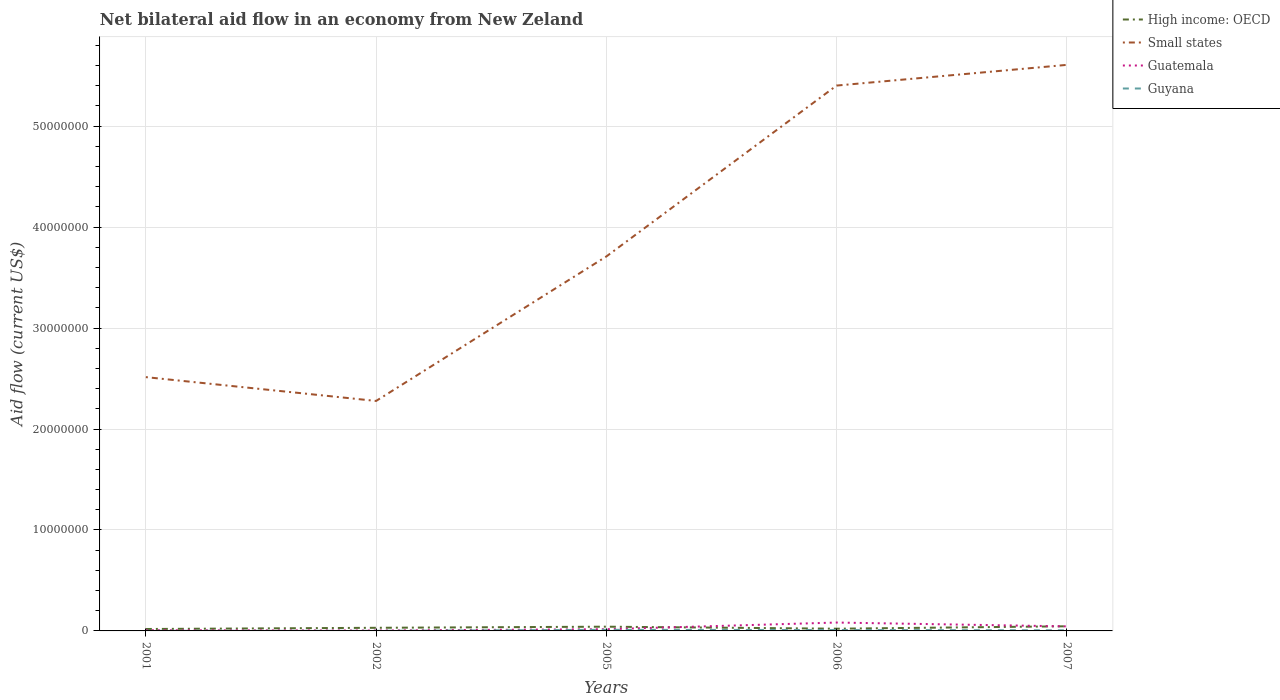How many different coloured lines are there?
Keep it short and to the point. 4. Does the line corresponding to Guyana intersect with the line corresponding to Small states?
Make the answer very short. No. Across all years, what is the maximum net bilateral aid flow in Guyana?
Offer a very short reply. 10000. In which year was the net bilateral aid flow in Small states maximum?
Keep it short and to the point. 2002. What is the total net bilateral aid flow in Small states in the graph?
Ensure brevity in your answer.  -2.05e+06. What is the difference between the highest and the second highest net bilateral aid flow in Guyana?
Keep it short and to the point. 1.00e+05. How many lines are there?
Your answer should be compact. 4. How many years are there in the graph?
Keep it short and to the point. 5. What is the difference between two consecutive major ticks on the Y-axis?
Your answer should be compact. 1.00e+07. Where does the legend appear in the graph?
Your answer should be very brief. Top right. How many legend labels are there?
Offer a very short reply. 4. How are the legend labels stacked?
Ensure brevity in your answer.  Vertical. What is the title of the graph?
Offer a terse response. Net bilateral aid flow in an economy from New Zeland. What is the label or title of the Y-axis?
Your answer should be very brief. Aid flow (current US$). What is the Aid flow (current US$) in Small states in 2001?
Provide a short and direct response. 2.51e+07. What is the Aid flow (current US$) of Guatemala in 2001?
Offer a very short reply. 7.00e+04. What is the Aid flow (current US$) of High income: OECD in 2002?
Provide a succinct answer. 3.10e+05. What is the Aid flow (current US$) of Small states in 2002?
Ensure brevity in your answer.  2.28e+07. What is the Aid flow (current US$) in Guatemala in 2002?
Provide a short and direct response. 4.00e+04. What is the Aid flow (current US$) in Small states in 2005?
Offer a very short reply. 3.71e+07. What is the Aid flow (current US$) in Guatemala in 2005?
Keep it short and to the point. 1.70e+05. What is the Aid flow (current US$) of High income: OECD in 2006?
Offer a terse response. 2.20e+05. What is the Aid flow (current US$) in Small states in 2006?
Offer a very short reply. 5.40e+07. What is the Aid flow (current US$) of Guatemala in 2006?
Keep it short and to the point. 8.30e+05. What is the Aid flow (current US$) of Small states in 2007?
Your response must be concise. 5.61e+07. What is the Aid flow (current US$) of Guatemala in 2007?
Ensure brevity in your answer.  4.50e+05. Across all years, what is the maximum Aid flow (current US$) in Small states?
Offer a very short reply. 5.61e+07. Across all years, what is the maximum Aid flow (current US$) in Guatemala?
Provide a succinct answer. 8.30e+05. Across all years, what is the minimum Aid flow (current US$) of High income: OECD?
Your answer should be compact. 1.90e+05. Across all years, what is the minimum Aid flow (current US$) of Small states?
Make the answer very short. 2.28e+07. Across all years, what is the minimum Aid flow (current US$) in Guatemala?
Your answer should be compact. 4.00e+04. Across all years, what is the minimum Aid flow (current US$) of Guyana?
Offer a very short reply. 10000. What is the total Aid flow (current US$) in High income: OECD in the graph?
Give a very brief answer. 1.60e+06. What is the total Aid flow (current US$) in Small states in the graph?
Your response must be concise. 1.95e+08. What is the total Aid flow (current US$) in Guatemala in the graph?
Your answer should be very brief. 1.56e+06. What is the total Aid flow (current US$) of Guyana in the graph?
Offer a very short reply. 2.80e+05. What is the difference between the Aid flow (current US$) of Small states in 2001 and that in 2002?
Provide a short and direct response. 2.36e+06. What is the difference between the Aid flow (current US$) in Guatemala in 2001 and that in 2002?
Your answer should be very brief. 3.00e+04. What is the difference between the Aid flow (current US$) in High income: OECD in 2001 and that in 2005?
Your response must be concise. -2.30e+05. What is the difference between the Aid flow (current US$) of Small states in 2001 and that in 2005?
Make the answer very short. -1.20e+07. What is the difference between the Aid flow (current US$) in Small states in 2001 and that in 2006?
Keep it short and to the point. -2.89e+07. What is the difference between the Aid flow (current US$) in Guatemala in 2001 and that in 2006?
Keep it short and to the point. -7.60e+05. What is the difference between the Aid flow (current US$) of Guyana in 2001 and that in 2006?
Ensure brevity in your answer.  -8.00e+04. What is the difference between the Aid flow (current US$) in Small states in 2001 and that in 2007?
Ensure brevity in your answer.  -3.09e+07. What is the difference between the Aid flow (current US$) in Guatemala in 2001 and that in 2007?
Your answer should be compact. -3.80e+05. What is the difference between the Aid flow (current US$) in High income: OECD in 2002 and that in 2005?
Your answer should be compact. -1.10e+05. What is the difference between the Aid flow (current US$) of Small states in 2002 and that in 2005?
Your answer should be very brief. -1.43e+07. What is the difference between the Aid flow (current US$) of Guyana in 2002 and that in 2005?
Make the answer very short. -1.00e+05. What is the difference between the Aid flow (current US$) in High income: OECD in 2002 and that in 2006?
Keep it short and to the point. 9.00e+04. What is the difference between the Aid flow (current US$) in Small states in 2002 and that in 2006?
Provide a succinct answer. -3.12e+07. What is the difference between the Aid flow (current US$) of Guatemala in 2002 and that in 2006?
Your answer should be very brief. -7.90e+05. What is the difference between the Aid flow (current US$) in Guyana in 2002 and that in 2006?
Keep it short and to the point. -8.00e+04. What is the difference between the Aid flow (current US$) of Small states in 2002 and that in 2007?
Make the answer very short. -3.33e+07. What is the difference between the Aid flow (current US$) of Guatemala in 2002 and that in 2007?
Provide a succinct answer. -4.10e+05. What is the difference between the Aid flow (current US$) in High income: OECD in 2005 and that in 2006?
Offer a very short reply. 2.00e+05. What is the difference between the Aid flow (current US$) of Small states in 2005 and that in 2006?
Give a very brief answer. -1.69e+07. What is the difference between the Aid flow (current US$) of Guatemala in 2005 and that in 2006?
Give a very brief answer. -6.60e+05. What is the difference between the Aid flow (current US$) in Small states in 2005 and that in 2007?
Provide a succinct answer. -1.90e+07. What is the difference between the Aid flow (current US$) in Guatemala in 2005 and that in 2007?
Offer a very short reply. -2.80e+05. What is the difference between the Aid flow (current US$) in Guyana in 2005 and that in 2007?
Your response must be concise. 5.00e+04. What is the difference between the Aid flow (current US$) of High income: OECD in 2006 and that in 2007?
Your response must be concise. -2.40e+05. What is the difference between the Aid flow (current US$) in Small states in 2006 and that in 2007?
Offer a terse response. -2.05e+06. What is the difference between the Aid flow (current US$) in Guatemala in 2006 and that in 2007?
Offer a very short reply. 3.80e+05. What is the difference between the Aid flow (current US$) in High income: OECD in 2001 and the Aid flow (current US$) in Small states in 2002?
Ensure brevity in your answer.  -2.26e+07. What is the difference between the Aid flow (current US$) of High income: OECD in 2001 and the Aid flow (current US$) of Guyana in 2002?
Give a very brief answer. 1.80e+05. What is the difference between the Aid flow (current US$) in Small states in 2001 and the Aid flow (current US$) in Guatemala in 2002?
Make the answer very short. 2.51e+07. What is the difference between the Aid flow (current US$) of Small states in 2001 and the Aid flow (current US$) of Guyana in 2002?
Provide a succinct answer. 2.51e+07. What is the difference between the Aid flow (current US$) in High income: OECD in 2001 and the Aid flow (current US$) in Small states in 2005?
Your response must be concise. -3.69e+07. What is the difference between the Aid flow (current US$) of Small states in 2001 and the Aid flow (current US$) of Guatemala in 2005?
Provide a short and direct response. 2.50e+07. What is the difference between the Aid flow (current US$) in Small states in 2001 and the Aid flow (current US$) in Guyana in 2005?
Give a very brief answer. 2.50e+07. What is the difference between the Aid flow (current US$) in High income: OECD in 2001 and the Aid flow (current US$) in Small states in 2006?
Your answer should be compact. -5.38e+07. What is the difference between the Aid flow (current US$) in High income: OECD in 2001 and the Aid flow (current US$) in Guatemala in 2006?
Ensure brevity in your answer.  -6.40e+05. What is the difference between the Aid flow (current US$) of Small states in 2001 and the Aid flow (current US$) of Guatemala in 2006?
Provide a succinct answer. 2.43e+07. What is the difference between the Aid flow (current US$) in Small states in 2001 and the Aid flow (current US$) in Guyana in 2006?
Your answer should be compact. 2.50e+07. What is the difference between the Aid flow (current US$) of Guatemala in 2001 and the Aid flow (current US$) of Guyana in 2006?
Offer a terse response. -2.00e+04. What is the difference between the Aid flow (current US$) of High income: OECD in 2001 and the Aid flow (current US$) of Small states in 2007?
Provide a short and direct response. -5.59e+07. What is the difference between the Aid flow (current US$) of Small states in 2001 and the Aid flow (current US$) of Guatemala in 2007?
Ensure brevity in your answer.  2.47e+07. What is the difference between the Aid flow (current US$) in Small states in 2001 and the Aid flow (current US$) in Guyana in 2007?
Provide a short and direct response. 2.51e+07. What is the difference between the Aid flow (current US$) of High income: OECD in 2002 and the Aid flow (current US$) of Small states in 2005?
Offer a terse response. -3.68e+07. What is the difference between the Aid flow (current US$) in High income: OECD in 2002 and the Aid flow (current US$) in Guatemala in 2005?
Your response must be concise. 1.40e+05. What is the difference between the Aid flow (current US$) of High income: OECD in 2002 and the Aid flow (current US$) of Guyana in 2005?
Make the answer very short. 2.00e+05. What is the difference between the Aid flow (current US$) in Small states in 2002 and the Aid flow (current US$) in Guatemala in 2005?
Provide a succinct answer. 2.26e+07. What is the difference between the Aid flow (current US$) in Small states in 2002 and the Aid flow (current US$) in Guyana in 2005?
Keep it short and to the point. 2.27e+07. What is the difference between the Aid flow (current US$) of Guatemala in 2002 and the Aid flow (current US$) of Guyana in 2005?
Your answer should be compact. -7.00e+04. What is the difference between the Aid flow (current US$) in High income: OECD in 2002 and the Aid flow (current US$) in Small states in 2006?
Provide a succinct answer. -5.37e+07. What is the difference between the Aid flow (current US$) in High income: OECD in 2002 and the Aid flow (current US$) in Guatemala in 2006?
Keep it short and to the point. -5.20e+05. What is the difference between the Aid flow (current US$) of Small states in 2002 and the Aid flow (current US$) of Guatemala in 2006?
Provide a succinct answer. 2.20e+07. What is the difference between the Aid flow (current US$) of Small states in 2002 and the Aid flow (current US$) of Guyana in 2006?
Offer a terse response. 2.27e+07. What is the difference between the Aid flow (current US$) in High income: OECD in 2002 and the Aid flow (current US$) in Small states in 2007?
Provide a short and direct response. -5.58e+07. What is the difference between the Aid flow (current US$) of High income: OECD in 2002 and the Aid flow (current US$) of Guyana in 2007?
Make the answer very short. 2.50e+05. What is the difference between the Aid flow (current US$) in Small states in 2002 and the Aid flow (current US$) in Guatemala in 2007?
Your response must be concise. 2.23e+07. What is the difference between the Aid flow (current US$) in Small states in 2002 and the Aid flow (current US$) in Guyana in 2007?
Your response must be concise. 2.27e+07. What is the difference between the Aid flow (current US$) in Guatemala in 2002 and the Aid flow (current US$) in Guyana in 2007?
Offer a terse response. -2.00e+04. What is the difference between the Aid flow (current US$) of High income: OECD in 2005 and the Aid flow (current US$) of Small states in 2006?
Provide a short and direct response. -5.36e+07. What is the difference between the Aid flow (current US$) of High income: OECD in 2005 and the Aid flow (current US$) of Guatemala in 2006?
Ensure brevity in your answer.  -4.10e+05. What is the difference between the Aid flow (current US$) of Small states in 2005 and the Aid flow (current US$) of Guatemala in 2006?
Offer a terse response. 3.63e+07. What is the difference between the Aid flow (current US$) in Small states in 2005 and the Aid flow (current US$) in Guyana in 2006?
Keep it short and to the point. 3.70e+07. What is the difference between the Aid flow (current US$) in High income: OECD in 2005 and the Aid flow (current US$) in Small states in 2007?
Keep it short and to the point. -5.56e+07. What is the difference between the Aid flow (current US$) of High income: OECD in 2005 and the Aid flow (current US$) of Guyana in 2007?
Provide a succinct answer. 3.60e+05. What is the difference between the Aid flow (current US$) of Small states in 2005 and the Aid flow (current US$) of Guatemala in 2007?
Your response must be concise. 3.66e+07. What is the difference between the Aid flow (current US$) in Small states in 2005 and the Aid flow (current US$) in Guyana in 2007?
Offer a terse response. 3.70e+07. What is the difference between the Aid flow (current US$) of High income: OECD in 2006 and the Aid flow (current US$) of Small states in 2007?
Make the answer very short. -5.58e+07. What is the difference between the Aid flow (current US$) of High income: OECD in 2006 and the Aid flow (current US$) of Guatemala in 2007?
Offer a very short reply. -2.30e+05. What is the difference between the Aid flow (current US$) of High income: OECD in 2006 and the Aid flow (current US$) of Guyana in 2007?
Your answer should be very brief. 1.60e+05. What is the difference between the Aid flow (current US$) in Small states in 2006 and the Aid flow (current US$) in Guatemala in 2007?
Provide a short and direct response. 5.36e+07. What is the difference between the Aid flow (current US$) of Small states in 2006 and the Aid flow (current US$) of Guyana in 2007?
Ensure brevity in your answer.  5.40e+07. What is the difference between the Aid flow (current US$) in Guatemala in 2006 and the Aid flow (current US$) in Guyana in 2007?
Give a very brief answer. 7.70e+05. What is the average Aid flow (current US$) of Small states per year?
Offer a very short reply. 3.90e+07. What is the average Aid flow (current US$) of Guatemala per year?
Offer a very short reply. 3.12e+05. What is the average Aid flow (current US$) in Guyana per year?
Ensure brevity in your answer.  5.60e+04. In the year 2001, what is the difference between the Aid flow (current US$) in High income: OECD and Aid flow (current US$) in Small states?
Keep it short and to the point. -2.50e+07. In the year 2001, what is the difference between the Aid flow (current US$) of High income: OECD and Aid flow (current US$) of Guatemala?
Offer a very short reply. 1.20e+05. In the year 2001, what is the difference between the Aid flow (current US$) in Small states and Aid flow (current US$) in Guatemala?
Offer a very short reply. 2.51e+07. In the year 2001, what is the difference between the Aid flow (current US$) in Small states and Aid flow (current US$) in Guyana?
Provide a short and direct response. 2.51e+07. In the year 2002, what is the difference between the Aid flow (current US$) in High income: OECD and Aid flow (current US$) in Small states?
Provide a short and direct response. -2.25e+07. In the year 2002, what is the difference between the Aid flow (current US$) of Small states and Aid flow (current US$) of Guatemala?
Your answer should be very brief. 2.27e+07. In the year 2002, what is the difference between the Aid flow (current US$) of Small states and Aid flow (current US$) of Guyana?
Offer a very short reply. 2.28e+07. In the year 2002, what is the difference between the Aid flow (current US$) of Guatemala and Aid flow (current US$) of Guyana?
Keep it short and to the point. 3.00e+04. In the year 2005, what is the difference between the Aid flow (current US$) of High income: OECD and Aid flow (current US$) of Small states?
Give a very brief answer. -3.67e+07. In the year 2005, what is the difference between the Aid flow (current US$) in Small states and Aid flow (current US$) in Guatemala?
Keep it short and to the point. 3.69e+07. In the year 2005, what is the difference between the Aid flow (current US$) in Small states and Aid flow (current US$) in Guyana?
Give a very brief answer. 3.70e+07. In the year 2005, what is the difference between the Aid flow (current US$) of Guatemala and Aid flow (current US$) of Guyana?
Your answer should be compact. 6.00e+04. In the year 2006, what is the difference between the Aid flow (current US$) of High income: OECD and Aid flow (current US$) of Small states?
Make the answer very short. -5.38e+07. In the year 2006, what is the difference between the Aid flow (current US$) of High income: OECD and Aid flow (current US$) of Guatemala?
Offer a very short reply. -6.10e+05. In the year 2006, what is the difference between the Aid flow (current US$) in Small states and Aid flow (current US$) in Guatemala?
Ensure brevity in your answer.  5.32e+07. In the year 2006, what is the difference between the Aid flow (current US$) in Small states and Aid flow (current US$) in Guyana?
Offer a very short reply. 5.39e+07. In the year 2006, what is the difference between the Aid flow (current US$) in Guatemala and Aid flow (current US$) in Guyana?
Your answer should be very brief. 7.40e+05. In the year 2007, what is the difference between the Aid flow (current US$) of High income: OECD and Aid flow (current US$) of Small states?
Give a very brief answer. -5.56e+07. In the year 2007, what is the difference between the Aid flow (current US$) in High income: OECD and Aid flow (current US$) in Guyana?
Ensure brevity in your answer.  4.00e+05. In the year 2007, what is the difference between the Aid flow (current US$) of Small states and Aid flow (current US$) of Guatemala?
Give a very brief answer. 5.56e+07. In the year 2007, what is the difference between the Aid flow (current US$) of Small states and Aid flow (current US$) of Guyana?
Provide a succinct answer. 5.60e+07. In the year 2007, what is the difference between the Aid flow (current US$) in Guatemala and Aid flow (current US$) in Guyana?
Offer a terse response. 3.90e+05. What is the ratio of the Aid flow (current US$) in High income: OECD in 2001 to that in 2002?
Your answer should be compact. 0.61. What is the ratio of the Aid flow (current US$) of Small states in 2001 to that in 2002?
Offer a terse response. 1.1. What is the ratio of the Aid flow (current US$) of High income: OECD in 2001 to that in 2005?
Keep it short and to the point. 0.45. What is the ratio of the Aid flow (current US$) of Small states in 2001 to that in 2005?
Make the answer very short. 0.68. What is the ratio of the Aid flow (current US$) in Guatemala in 2001 to that in 2005?
Provide a succinct answer. 0.41. What is the ratio of the Aid flow (current US$) of Guyana in 2001 to that in 2005?
Your answer should be compact. 0.09. What is the ratio of the Aid flow (current US$) in High income: OECD in 2001 to that in 2006?
Your answer should be very brief. 0.86. What is the ratio of the Aid flow (current US$) of Small states in 2001 to that in 2006?
Provide a succinct answer. 0.47. What is the ratio of the Aid flow (current US$) in Guatemala in 2001 to that in 2006?
Offer a very short reply. 0.08. What is the ratio of the Aid flow (current US$) in Guyana in 2001 to that in 2006?
Provide a short and direct response. 0.11. What is the ratio of the Aid flow (current US$) of High income: OECD in 2001 to that in 2007?
Provide a short and direct response. 0.41. What is the ratio of the Aid flow (current US$) in Small states in 2001 to that in 2007?
Your answer should be compact. 0.45. What is the ratio of the Aid flow (current US$) of Guatemala in 2001 to that in 2007?
Provide a succinct answer. 0.16. What is the ratio of the Aid flow (current US$) in High income: OECD in 2002 to that in 2005?
Your response must be concise. 0.74. What is the ratio of the Aid flow (current US$) of Small states in 2002 to that in 2005?
Keep it short and to the point. 0.61. What is the ratio of the Aid flow (current US$) of Guatemala in 2002 to that in 2005?
Keep it short and to the point. 0.24. What is the ratio of the Aid flow (current US$) in Guyana in 2002 to that in 2005?
Provide a succinct answer. 0.09. What is the ratio of the Aid flow (current US$) in High income: OECD in 2002 to that in 2006?
Your answer should be very brief. 1.41. What is the ratio of the Aid flow (current US$) of Small states in 2002 to that in 2006?
Offer a terse response. 0.42. What is the ratio of the Aid flow (current US$) of Guatemala in 2002 to that in 2006?
Offer a very short reply. 0.05. What is the ratio of the Aid flow (current US$) of High income: OECD in 2002 to that in 2007?
Provide a succinct answer. 0.67. What is the ratio of the Aid flow (current US$) of Small states in 2002 to that in 2007?
Offer a terse response. 0.41. What is the ratio of the Aid flow (current US$) in Guatemala in 2002 to that in 2007?
Your answer should be compact. 0.09. What is the ratio of the Aid flow (current US$) of Guyana in 2002 to that in 2007?
Your answer should be compact. 0.17. What is the ratio of the Aid flow (current US$) in High income: OECD in 2005 to that in 2006?
Provide a short and direct response. 1.91. What is the ratio of the Aid flow (current US$) of Small states in 2005 to that in 2006?
Offer a terse response. 0.69. What is the ratio of the Aid flow (current US$) of Guatemala in 2005 to that in 2006?
Ensure brevity in your answer.  0.2. What is the ratio of the Aid flow (current US$) of Guyana in 2005 to that in 2006?
Ensure brevity in your answer.  1.22. What is the ratio of the Aid flow (current US$) in Small states in 2005 to that in 2007?
Offer a terse response. 0.66. What is the ratio of the Aid flow (current US$) of Guatemala in 2005 to that in 2007?
Your answer should be very brief. 0.38. What is the ratio of the Aid flow (current US$) of Guyana in 2005 to that in 2007?
Your answer should be compact. 1.83. What is the ratio of the Aid flow (current US$) of High income: OECD in 2006 to that in 2007?
Ensure brevity in your answer.  0.48. What is the ratio of the Aid flow (current US$) of Small states in 2006 to that in 2007?
Your answer should be very brief. 0.96. What is the ratio of the Aid flow (current US$) in Guatemala in 2006 to that in 2007?
Your answer should be very brief. 1.84. What is the ratio of the Aid flow (current US$) in Guyana in 2006 to that in 2007?
Offer a very short reply. 1.5. What is the difference between the highest and the second highest Aid flow (current US$) of High income: OECD?
Offer a terse response. 4.00e+04. What is the difference between the highest and the second highest Aid flow (current US$) in Small states?
Keep it short and to the point. 2.05e+06. What is the difference between the highest and the second highest Aid flow (current US$) in Guyana?
Offer a terse response. 2.00e+04. What is the difference between the highest and the lowest Aid flow (current US$) of High income: OECD?
Offer a very short reply. 2.70e+05. What is the difference between the highest and the lowest Aid flow (current US$) in Small states?
Make the answer very short. 3.33e+07. What is the difference between the highest and the lowest Aid flow (current US$) in Guatemala?
Make the answer very short. 7.90e+05. What is the difference between the highest and the lowest Aid flow (current US$) of Guyana?
Your response must be concise. 1.00e+05. 